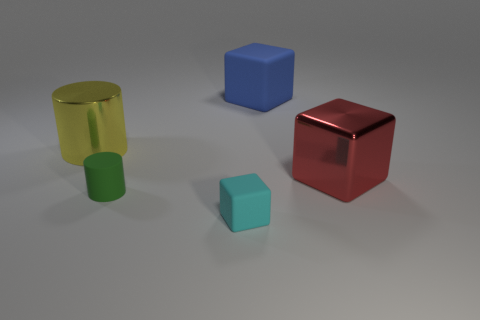Are there any other things that are the same size as the red cube?
Offer a terse response. Yes. Does the cyan matte object have the same shape as the red object?
Your response must be concise. Yes. Are there an equal number of big red objects behind the big red object and objects to the right of the tiny rubber cylinder?
Offer a terse response. No. How many other objects are the same material as the big blue cube?
Your response must be concise. 2. What number of big objects are cyan rubber things or gray matte things?
Provide a succinct answer. 0. Are there an equal number of large blue rubber objects to the left of the yellow cylinder and tiny red metallic objects?
Ensure brevity in your answer.  Yes. Are there any small cyan objects right of the tiny thing that is in front of the small green rubber thing?
Ensure brevity in your answer.  No. What number of other objects are the same color as the metal block?
Your response must be concise. 0. The large metallic block is what color?
Provide a short and direct response. Red. What size is the object that is in front of the blue block and right of the cyan thing?
Your answer should be compact. Large. 